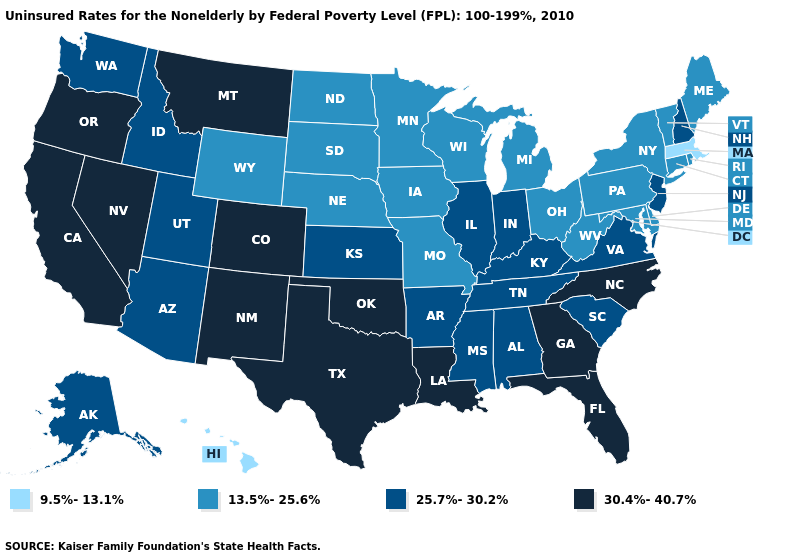What is the value of California?
Keep it brief. 30.4%-40.7%. Does South Dakota have a lower value than New York?
Write a very short answer. No. Name the states that have a value in the range 9.5%-13.1%?
Be succinct. Hawaii, Massachusetts. Does Massachusetts have the lowest value in the USA?
Short answer required. Yes. Does Massachusetts have the lowest value in the Northeast?
Write a very short answer. Yes. What is the value of Mississippi?
Be succinct. 25.7%-30.2%. Which states have the highest value in the USA?
Answer briefly. California, Colorado, Florida, Georgia, Louisiana, Montana, Nevada, New Mexico, North Carolina, Oklahoma, Oregon, Texas. Does Maryland have the lowest value in the USA?
Short answer required. No. Does Oklahoma have the highest value in the USA?
Quick response, please. Yes. Among the states that border Connecticut , which have the lowest value?
Keep it brief. Massachusetts. Does Oklahoma have the same value as Nevada?
Answer briefly. Yes. What is the value of Oklahoma?
Write a very short answer. 30.4%-40.7%. What is the value of Michigan?
Give a very brief answer. 13.5%-25.6%. Among the states that border Connecticut , which have the lowest value?
Write a very short answer. Massachusetts. Name the states that have a value in the range 25.7%-30.2%?
Quick response, please. Alabama, Alaska, Arizona, Arkansas, Idaho, Illinois, Indiana, Kansas, Kentucky, Mississippi, New Hampshire, New Jersey, South Carolina, Tennessee, Utah, Virginia, Washington. 